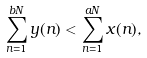<formula> <loc_0><loc_0><loc_500><loc_500>\sum _ { n = 1 } ^ { b N } y ( n ) < \sum _ { n = 1 } ^ { a N } x ( n ) ,</formula> 